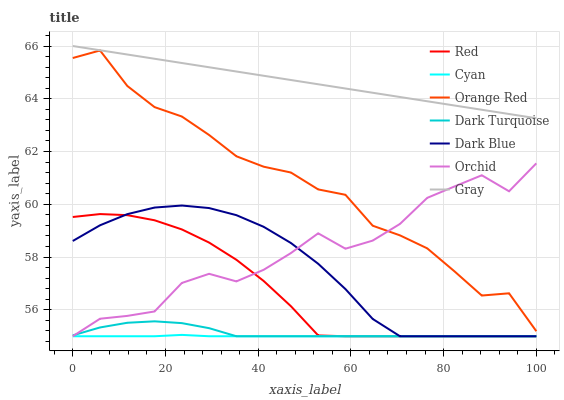Does Cyan have the minimum area under the curve?
Answer yes or no. Yes. Does Gray have the maximum area under the curve?
Answer yes or no. Yes. Does Dark Turquoise have the minimum area under the curve?
Answer yes or no. No. Does Dark Turquoise have the maximum area under the curve?
Answer yes or no. No. Is Gray the smoothest?
Answer yes or no. Yes. Is Orchid the roughest?
Answer yes or no. Yes. Is Dark Turquoise the smoothest?
Answer yes or no. No. Is Dark Turquoise the roughest?
Answer yes or no. No. Does Dark Turquoise have the lowest value?
Answer yes or no. Yes. Does Orange Red have the lowest value?
Answer yes or no. No. Does Gray have the highest value?
Answer yes or no. Yes. Does Dark Turquoise have the highest value?
Answer yes or no. No. Is Dark Blue less than Orange Red?
Answer yes or no. Yes. Is Gray greater than Red?
Answer yes or no. Yes. Does Dark Turquoise intersect Dark Blue?
Answer yes or no. Yes. Is Dark Turquoise less than Dark Blue?
Answer yes or no. No. Is Dark Turquoise greater than Dark Blue?
Answer yes or no. No. Does Dark Blue intersect Orange Red?
Answer yes or no. No. 